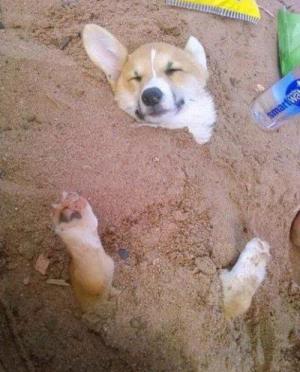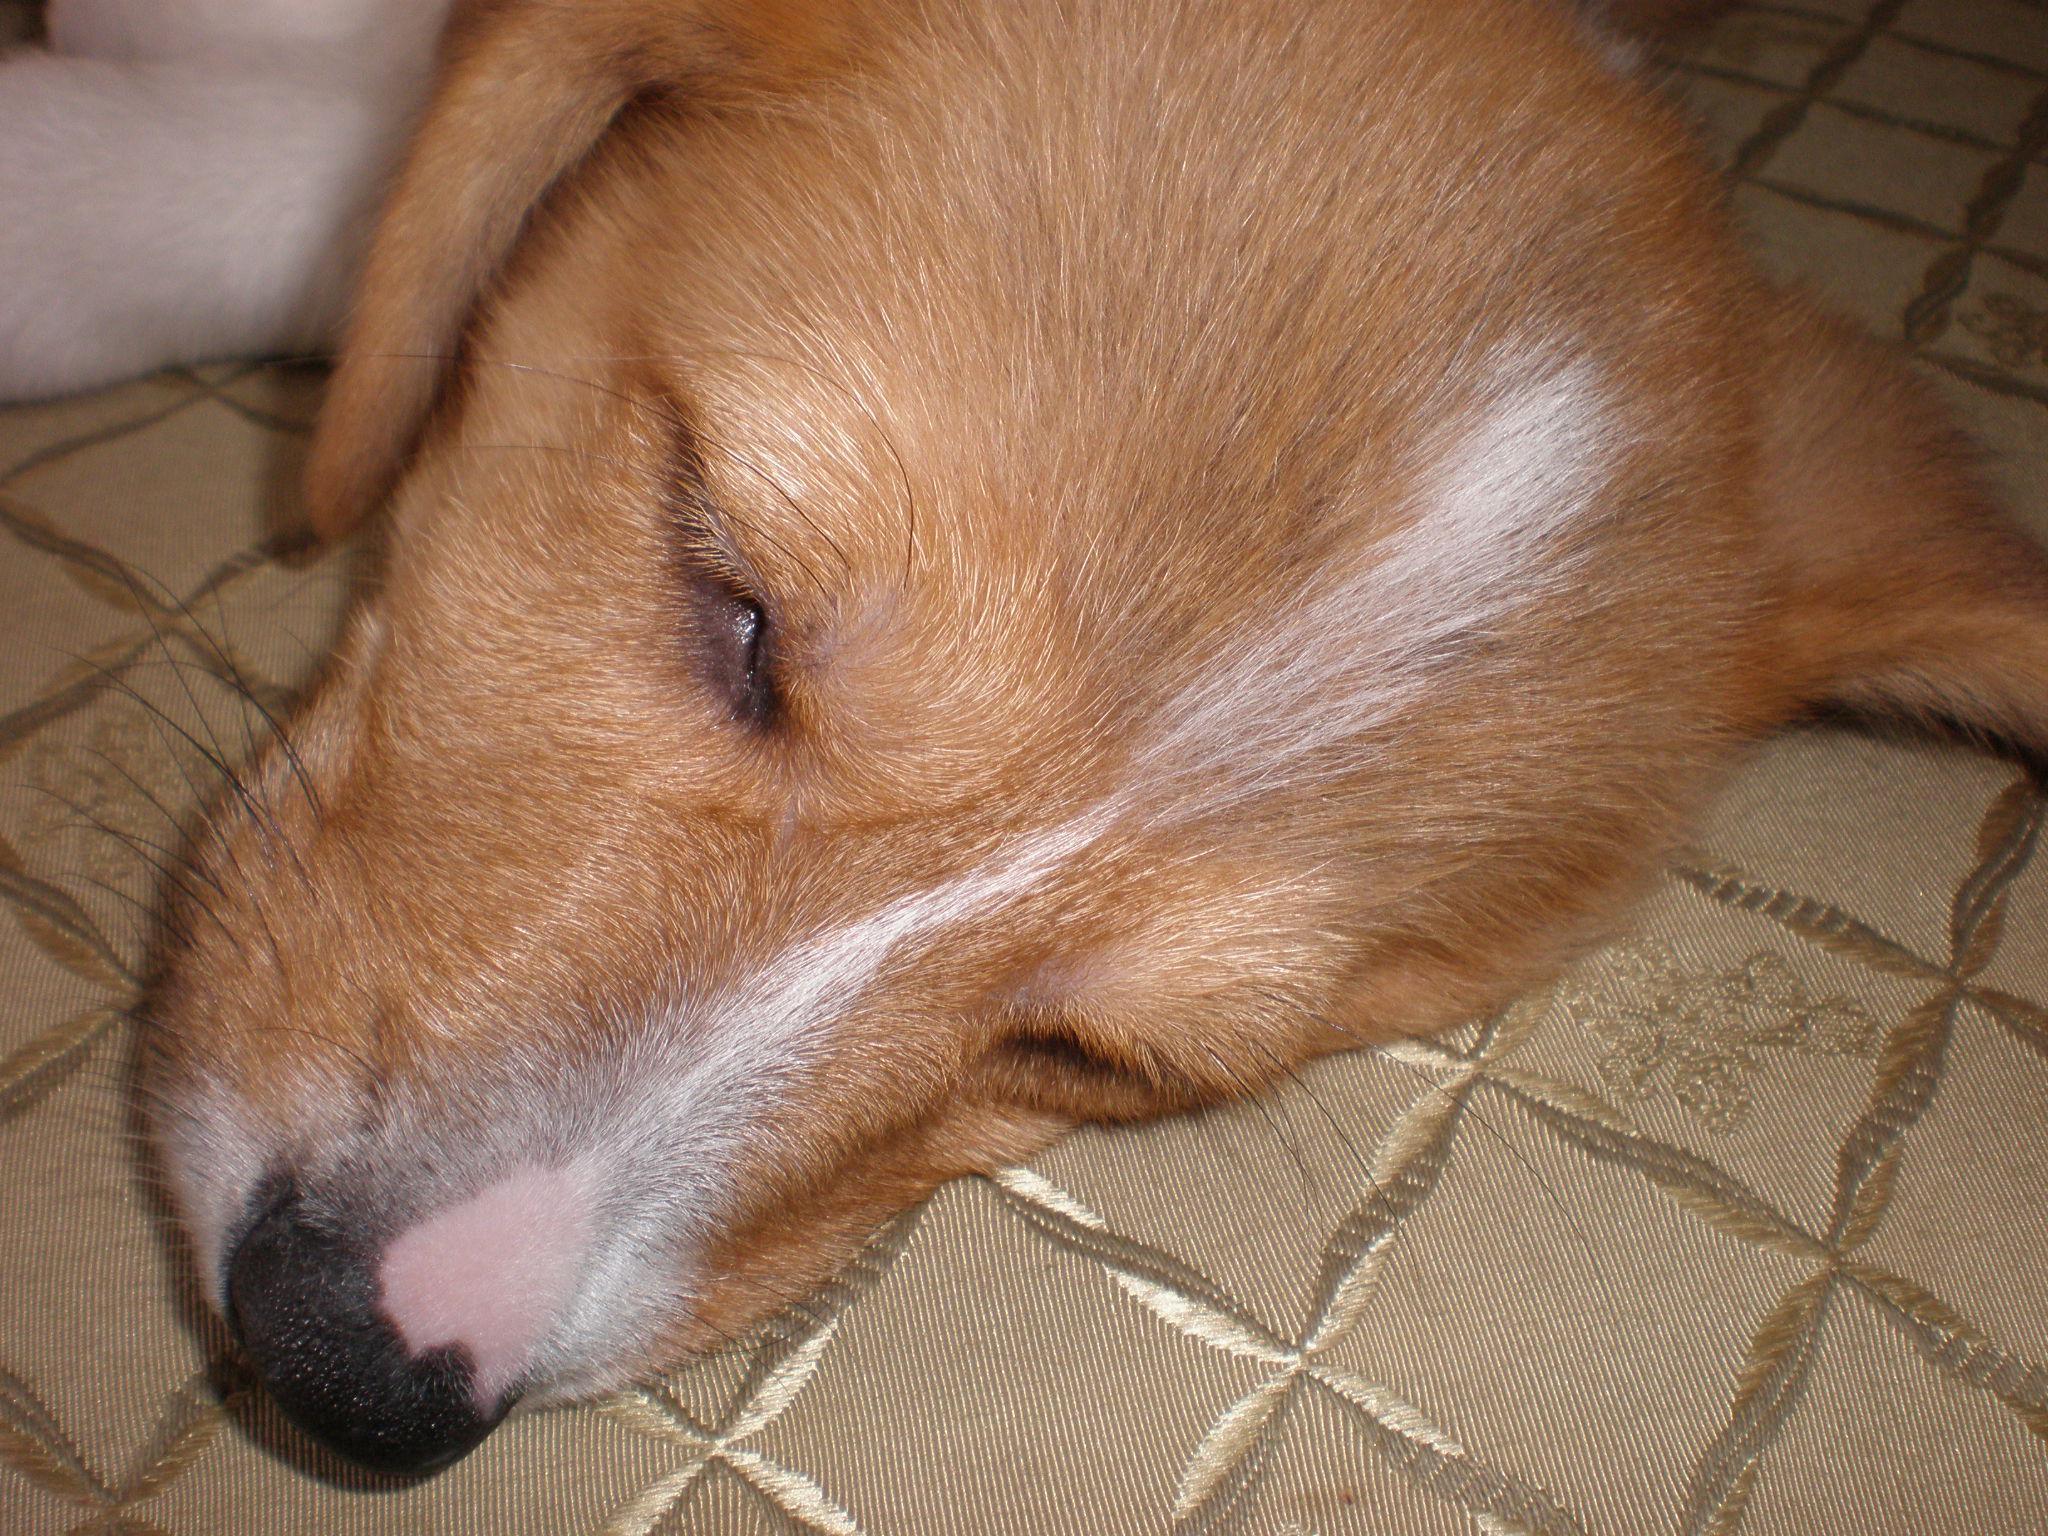The first image is the image on the left, the second image is the image on the right. Considering the images on both sides, is "Each image shows one orange-and-white corgi dog, each image shows a dog lying on its back, and one dog is wearing a bluish collar." valid? Answer yes or no. No. The first image is the image on the left, the second image is the image on the right. Evaluate the accuracy of this statement regarding the images: "Both dogs are sleeping on their backs.". Is it true? Answer yes or no. No. 